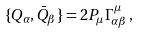Convert formula to latex. <formula><loc_0><loc_0><loc_500><loc_500>\{ Q _ { \alpha } , \bar { Q } _ { \beta } \} = 2 P _ { \mu } \Gamma ^ { \mu } _ { \alpha \beta } \, ,</formula> 